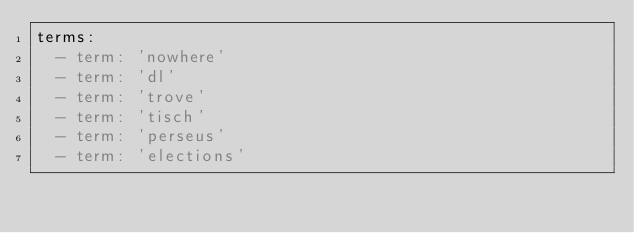<code> <loc_0><loc_0><loc_500><loc_500><_YAML_>terms:
  - term: 'nowhere'
  - term: 'dl'
  - term: 'trove'
  - term: 'tisch'
  - term: 'perseus'
  - term: 'elections'
</code> 